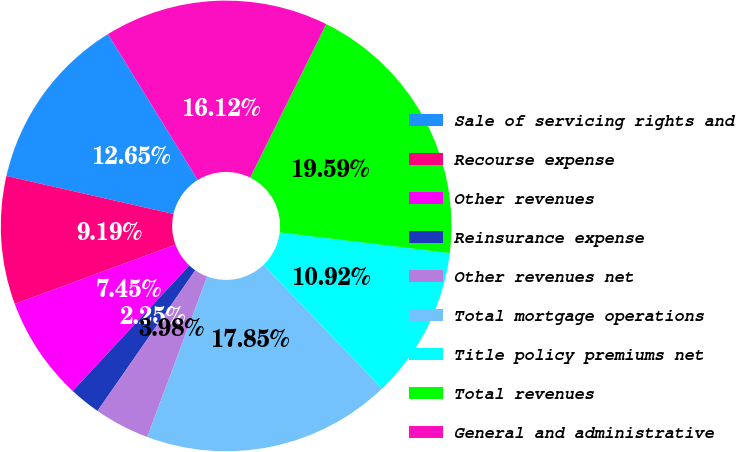Convert chart. <chart><loc_0><loc_0><loc_500><loc_500><pie_chart><fcel>Sale of servicing rights and<fcel>Recourse expense<fcel>Other revenues<fcel>Reinsurance expense<fcel>Other revenues net<fcel>Total mortgage operations<fcel>Title policy premiums net<fcel>Total revenues<fcel>General and administrative<nl><fcel>12.65%<fcel>9.19%<fcel>7.45%<fcel>2.25%<fcel>3.98%<fcel>17.85%<fcel>10.92%<fcel>19.59%<fcel>16.12%<nl></chart> 